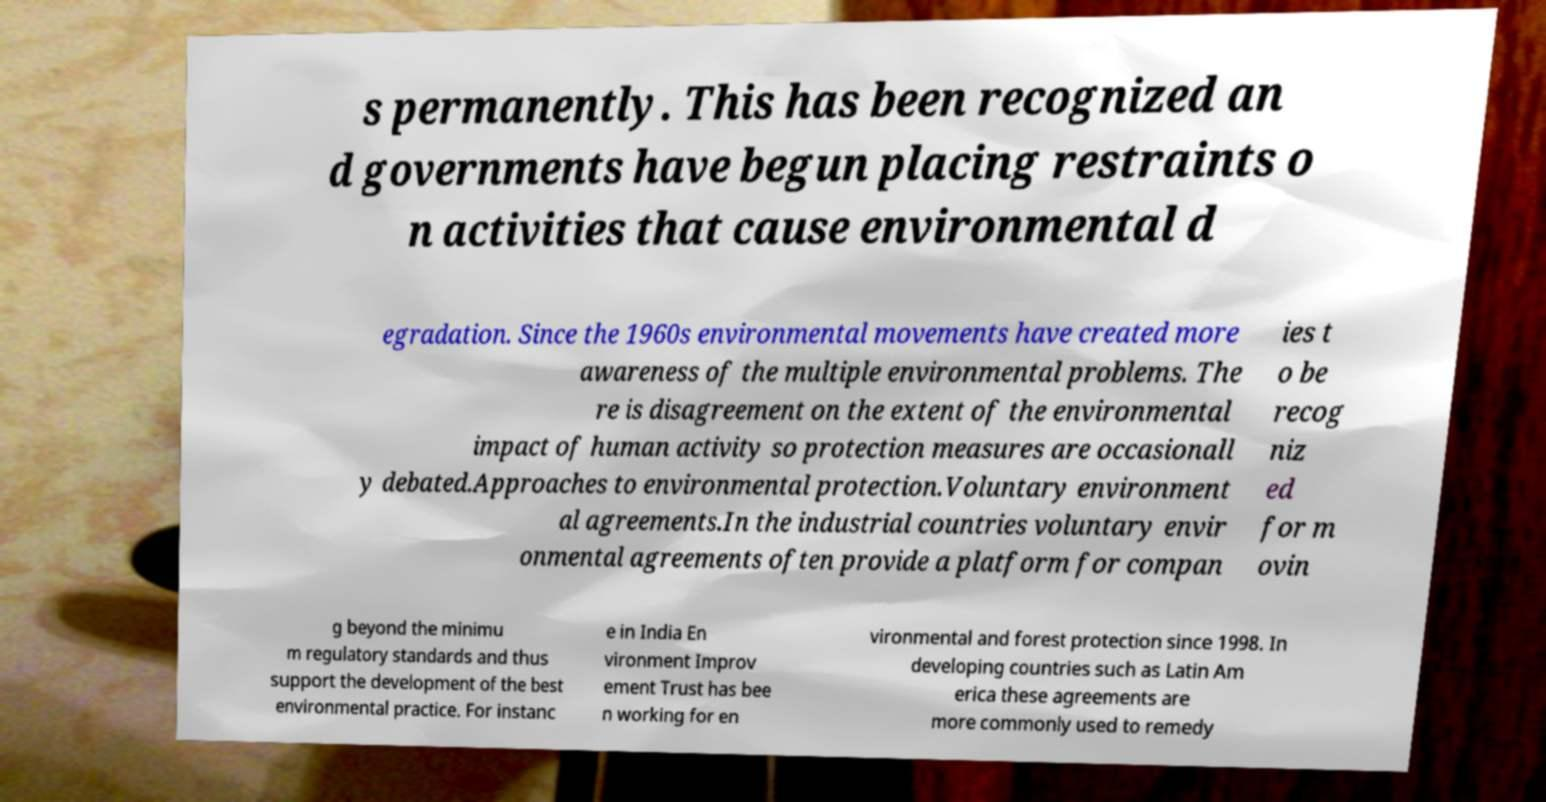I need the written content from this picture converted into text. Can you do that? s permanently. This has been recognized an d governments have begun placing restraints o n activities that cause environmental d egradation. Since the 1960s environmental movements have created more awareness of the multiple environmental problems. The re is disagreement on the extent of the environmental impact of human activity so protection measures are occasionall y debated.Approaches to environmental protection.Voluntary environment al agreements.In the industrial countries voluntary envir onmental agreements often provide a platform for compan ies t o be recog niz ed for m ovin g beyond the minimu m regulatory standards and thus support the development of the best environmental practice. For instanc e in India En vironment Improv ement Trust has bee n working for en vironmental and forest protection since 1998. In developing countries such as Latin Am erica these agreements are more commonly used to remedy 